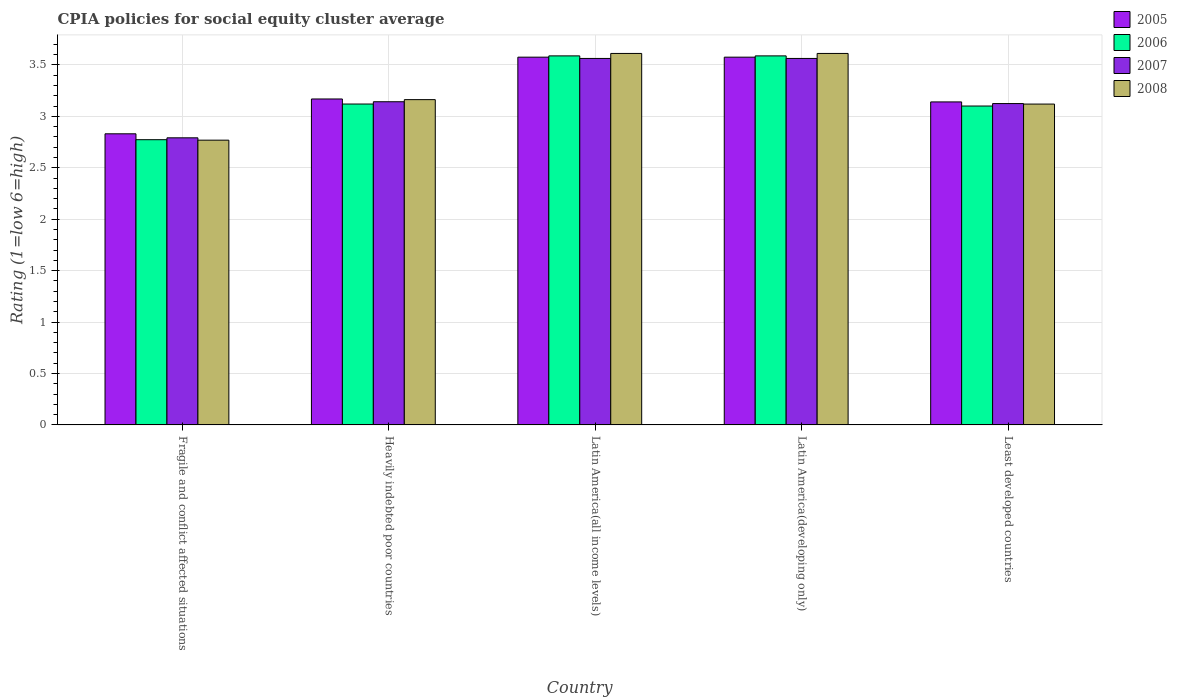How many groups of bars are there?
Provide a succinct answer. 5. What is the label of the 2nd group of bars from the left?
Provide a succinct answer. Heavily indebted poor countries. What is the CPIA rating in 2005 in Least developed countries?
Your answer should be very brief. 3.14. Across all countries, what is the maximum CPIA rating in 2007?
Provide a succinct answer. 3.56. Across all countries, what is the minimum CPIA rating in 2008?
Offer a terse response. 2.77. In which country was the CPIA rating in 2008 maximum?
Keep it short and to the point. Latin America(all income levels). In which country was the CPIA rating in 2008 minimum?
Ensure brevity in your answer.  Fragile and conflict affected situations. What is the total CPIA rating in 2008 in the graph?
Give a very brief answer. 16.27. What is the difference between the CPIA rating in 2008 in Latin America(all income levels) and that in Latin America(developing only)?
Make the answer very short. 0. What is the difference between the CPIA rating in 2008 in Heavily indebted poor countries and the CPIA rating in 2007 in Latin America(developing only)?
Provide a short and direct response. -0.4. What is the average CPIA rating in 2006 per country?
Provide a short and direct response. 3.23. What is the difference between the CPIA rating of/in 2007 and CPIA rating of/in 2006 in Fragile and conflict affected situations?
Offer a terse response. 0.02. In how many countries, is the CPIA rating in 2007 greater than 0.5?
Make the answer very short. 5. What is the ratio of the CPIA rating in 2006 in Fragile and conflict affected situations to that in Heavily indebted poor countries?
Ensure brevity in your answer.  0.89. What is the difference between the highest and the second highest CPIA rating in 2005?
Your response must be concise. -0.41. What is the difference between the highest and the lowest CPIA rating in 2006?
Your response must be concise. 0.81. In how many countries, is the CPIA rating in 2007 greater than the average CPIA rating in 2007 taken over all countries?
Offer a very short reply. 2. Is it the case that in every country, the sum of the CPIA rating in 2005 and CPIA rating in 2008 is greater than the sum of CPIA rating in 2007 and CPIA rating in 2006?
Your response must be concise. No. What does the 2nd bar from the right in Latin America(developing only) represents?
Ensure brevity in your answer.  2007. Is it the case that in every country, the sum of the CPIA rating in 2008 and CPIA rating in 2005 is greater than the CPIA rating in 2006?
Your response must be concise. Yes. What is the difference between two consecutive major ticks on the Y-axis?
Provide a short and direct response. 0.5. Where does the legend appear in the graph?
Your answer should be compact. Top right. How are the legend labels stacked?
Offer a very short reply. Vertical. What is the title of the graph?
Provide a short and direct response. CPIA policies for social equity cluster average. What is the label or title of the X-axis?
Your response must be concise. Country. What is the label or title of the Y-axis?
Your answer should be very brief. Rating (1=low 6=high). What is the Rating (1=low 6=high) in 2005 in Fragile and conflict affected situations?
Keep it short and to the point. 2.83. What is the Rating (1=low 6=high) of 2006 in Fragile and conflict affected situations?
Make the answer very short. 2.77. What is the Rating (1=low 6=high) of 2007 in Fragile and conflict affected situations?
Offer a very short reply. 2.79. What is the Rating (1=low 6=high) of 2008 in Fragile and conflict affected situations?
Give a very brief answer. 2.77. What is the Rating (1=low 6=high) in 2005 in Heavily indebted poor countries?
Make the answer very short. 3.17. What is the Rating (1=low 6=high) of 2006 in Heavily indebted poor countries?
Keep it short and to the point. 3.12. What is the Rating (1=low 6=high) of 2007 in Heavily indebted poor countries?
Offer a very short reply. 3.14. What is the Rating (1=low 6=high) in 2008 in Heavily indebted poor countries?
Keep it short and to the point. 3.16. What is the Rating (1=low 6=high) in 2005 in Latin America(all income levels)?
Provide a short and direct response. 3.58. What is the Rating (1=low 6=high) of 2006 in Latin America(all income levels)?
Offer a very short reply. 3.59. What is the Rating (1=low 6=high) in 2007 in Latin America(all income levels)?
Your response must be concise. 3.56. What is the Rating (1=low 6=high) in 2008 in Latin America(all income levels)?
Make the answer very short. 3.61. What is the Rating (1=low 6=high) of 2005 in Latin America(developing only)?
Provide a succinct answer. 3.58. What is the Rating (1=low 6=high) in 2006 in Latin America(developing only)?
Provide a succinct answer. 3.59. What is the Rating (1=low 6=high) in 2007 in Latin America(developing only)?
Provide a short and direct response. 3.56. What is the Rating (1=low 6=high) in 2008 in Latin America(developing only)?
Keep it short and to the point. 3.61. What is the Rating (1=low 6=high) in 2005 in Least developed countries?
Keep it short and to the point. 3.14. What is the Rating (1=low 6=high) in 2007 in Least developed countries?
Ensure brevity in your answer.  3.12. What is the Rating (1=low 6=high) in 2008 in Least developed countries?
Your answer should be compact. 3.12. Across all countries, what is the maximum Rating (1=low 6=high) in 2005?
Ensure brevity in your answer.  3.58. Across all countries, what is the maximum Rating (1=low 6=high) in 2006?
Offer a terse response. 3.59. Across all countries, what is the maximum Rating (1=low 6=high) in 2007?
Keep it short and to the point. 3.56. Across all countries, what is the maximum Rating (1=low 6=high) of 2008?
Your answer should be very brief. 3.61. Across all countries, what is the minimum Rating (1=low 6=high) of 2005?
Your answer should be compact. 2.83. Across all countries, what is the minimum Rating (1=low 6=high) in 2006?
Offer a very short reply. 2.77. Across all countries, what is the minimum Rating (1=low 6=high) of 2007?
Ensure brevity in your answer.  2.79. Across all countries, what is the minimum Rating (1=low 6=high) in 2008?
Your answer should be very brief. 2.77. What is the total Rating (1=low 6=high) in 2005 in the graph?
Provide a succinct answer. 16.29. What is the total Rating (1=low 6=high) of 2006 in the graph?
Offer a very short reply. 16.17. What is the total Rating (1=low 6=high) in 2007 in the graph?
Provide a succinct answer. 16.18. What is the total Rating (1=low 6=high) of 2008 in the graph?
Give a very brief answer. 16.27. What is the difference between the Rating (1=low 6=high) in 2005 in Fragile and conflict affected situations and that in Heavily indebted poor countries?
Offer a terse response. -0.34. What is the difference between the Rating (1=low 6=high) in 2006 in Fragile and conflict affected situations and that in Heavily indebted poor countries?
Offer a terse response. -0.35. What is the difference between the Rating (1=low 6=high) in 2007 in Fragile and conflict affected situations and that in Heavily indebted poor countries?
Offer a very short reply. -0.35. What is the difference between the Rating (1=low 6=high) of 2008 in Fragile and conflict affected situations and that in Heavily indebted poor countries?
Make the answer very short. -0.39. What is the difference between the Rating (1=low 6=high) of 2005 in Fragile and conflict affected situations and that in Latin America(all income levels)?
Your answer should be very brief. -0.74. What is the difference between the Rating (1=low 6=high) of 2006 in Fragile and conflict affected situations and that in Latin America(all income levels)?
Your answer should be very brief. -0.81. What is the difference between the Rating (1=low 6=high) in 2007 in Fragile and conflict affected situations and that in Latin America(all income levels)?
Offer a very short reply. -0.77. What is the difference between the Rating (1=low 6=high) in 2008 in Fragile and conflict affected situations and that in Latin America(all income levels)?
Ensure brevity in your answer.  -0.84. What is the difference between the Rating (1=low 6=high) of 2005 in Fragile and conflict affected situations and that in Latin America(developing only)?
Your answer should be very brief. -0.74. What is the difference between the Rating (1=low 6=high) of 2006 in Fragile and conflict affected situations and that in Latin America(developing only)?
Make the answer very short. -0.81. What is the difference between the Rating (1=low 6=high) in 2007 in Fragile and conflict affected situations and that in Latin America(developing only)?
Give a very brief answer. -0.77. What is the difference between the Rating (1=low 6=high) in 2008 in Fragile and conflict affected situations and that in Latin America(developing only)?
Offer a very short reply. -0.84. What is the difference between the Rating (1=low 6=high) in 2005 in Fragile and conflict affected situations and that in Least developed countries?
Your answer should be compact. -0.31. What is the difference between the Rating (1=low 6=high) of 2006 in Fragile and conflict affected situations and that in Least developed countries?
Your answer should be compact. -0.33. What is the difference between the Rating (1=low 6=high) in 2007 in Fragile and conflict affected situations and that in Least developed countries?
Provide a succinct answer. -0.33. What is the difference between the Rating (1=low 6=high) of 2008 in Fragile and conflict affected situations and that in Least developed countries?
Offer a terse response. -0.35. What is the difference between the Rating (1=low 6=high) of 2005 in Heavily indebted poor countries and that in Latin America(all income levels)?
Ensure brevity in your answer.  -0.41. What is the difference between the Rating (1=low 6=high) of 2006 in Heavily indebted poor countries and that in Latin America(all income levels)?
Your answer should be compact. -0.47. What is the difference between the Rating (1=low 6=high) in 2007 in Heavily indebted poor countries and that in Latin America(all income levels)?
Your answer should be compact. -0.42. What is the difference between the Rating (1=low 6=high) of 2008 in Heavily indebted poor countries and that in Latin America(all income levels)?
Offer a terse response. -0.45. What is the difference between the Rating (1=low 6=high) in 2005 in Heavily indebted poor countries and that in Latin America(developing only)?
Provide a succinct answer. -0.41. What is the difference between the Rating (1=low 6=high) of 2006 in Heavily indebted poor countries and that in Latin America(developing only)?
Provide a short and direct response. -0.47. What is the difference between the Rating (1=low 6=high) in 2007 in Heavily indebted poor countries and that in Latin America(developing only)?
Provide a succinct answer. -0.42. What is the difference between the Rating (1=low 6=high) of 2008 in Heavily indebted poor countries and that in Latin America(developing only)?
Make the answer very short. -0.45. What is the difference between the Rating (1=low 6=high) of 2005 in Heavily indebted poor countries and that in Least developed countries?
Make the answer very short. 0.03. What is the difference between the Rating (1=low 6=high) of 2006 in Heavily indebted poor countries and that in Least developed countries?
Make the answer very short. 0.02. What is the difference between the Rating (1=low 6=high) in 2007 in Heavily indebted poor countries and that in Least developed countries?
Give a very brief answer. 0.02. What is the difference between the Rating (1=low 6=high) of 2008 in Heavily indebted poor countries and that in Least developed countries?
Offer a very short reply. 0.04. What is the difference between the Rating (1=low 6=high) in 2006 in Latin America(all income levels) and that in Latin America(developing only)?
Offer a very short reply. 0. What is the difference between the Rating (1=low 6=high) in 2007 in Latin America(all income levels) and that in Latin America(developing only)?
Provide a succinct answer. 0. What is the difference between the Rating (1=low 6=high) of 2008 in Latin America(all income levels) and that in Latin America(developing only)?
Provide a succinct answer. 0. What is the difference between the Rating (1=low 6=high) of 2005 in Latin America(all income levels) and that in Least developed countries?
Offer a very short reply. 0.43. What is the difference between the Rating (1=low 6=high) of 2006 in Latin America(all income levels) and that in Least developed countries?
Your response must be concise. 0.49. What is the difference between the Rating (1=low 6=high) in 2007 in Latin America(all income levels) and that in Least developed countries?
Provide a short and direct response. 0.44. What is the difference between the Rating (1=low 6=high) in 2008 in Latin America(all income levels) and that in Least developed countries?
Offer a terse response. 0.49. What is the difference between the Rating (1=low 6=high) of 2005 in Latin America(developing only) and that in Least developed countries?
Ensure brevity in your answer.  0.43. What is the difference between the Rating (1=low 6=high) in 2006 in Latin America(developing only) and that in Least developed countries?
Your response must be concise. 0.49. What is the difference between the Rating (1=low 6=high) in 2007 in Latin America(developing only) and that in Least developed countries?
Give a very brief answer. 0.44. What is the difference between the Rating (1=low 6=high) of 2008 in Latin America(developing only) and that in Least developed countries?
Your response must be concise. 0.49. What is the difference between the Rating (1=low 6=high) in 2005 in Fragile and conflict affected situations and the Rating (1=low 6=high) in 2006 in Heavily indebted poor countries?
Ensure brevity in your answer.  -0.29. What is the difference between the Rating (1=low 6=high) of 2005 in Fragile and conflict affected situations and the Rating (1=low 6=high) of 2007 in Heavily indebted poor countries?
Offer a very short reply. -0.31. What is the difference between the Rating (1=low 6=high) in 2005 in Fragile and conflict affected situations and the Rating (1=low 6=high) in 2008 in Heavily indebted poor countries?
Keep it short and to the point. -0.33. What is the difference between the Rating (1=low 6=high) of 2006 in Fragile and conflict affected situations and the Rating (1=low 6=high) of 2007 in Heavily indebted poor countries?
Give a very brief answer. -0.37. What is the difference between the Rating (1=low 6=high) in 2006 in Fragile and conflict affected situations and the Rating (1=low 6=high) in 2008 in Heavily indebted poor countries?
Keep it short and to the point. -0.39. What is the difference between the Rating (1=low 6=high) of 2007 in Fragile and conflict affected situations and the Rating (1=low 6=high) of 2008 in Heavily indebted poor countries?
Give a very brief answer. -0.37. What is the difference between the Rating (1=low 6=high) of 2005 in Fragile and conflict affected situations and the Rating (1=low 6=high) of 2006 in Latin America(all income levels)?
Keep it short and to the point. -0.76. What is the difference between the Rating (1=low 6=high) of 2005 in Fragile and conflict affected situations and the Rating (1=low 6=high) of 2007 in Latin America(all income levels)?
Give a very brief answer. -0.73. What is the difference between the Rating (1=low 6=high) in 2005 in Fragile and conflict affected situations and the Rating (1=low 6=high) in 2008 in Latin America(all income levels)?
Your response must be concise. -0.78. What is the difference between the Rating (1=low 6=high) of 2006 in Fragile and conflict affected situations and the Rating (1=low 6=high) of 2007 in Latin America(all income levels)?
Offer a terse response. -0.79. What is the difference between the Rating (1=low 6=high) in 2006 in Fragile and conflict affected situations and the Rating (1=low 6=high) in 2008 in Latin America(all income levels)?
Your answer should be compact. -0.84. What is the difference between the Rating (1=low 6=high) of 2007 in Fragile and conflict affected situations and the Rating (1=low 6=high) of 2008 in Latin America(all income levels)?
Offer a very short reply. -0.82. What is the difference between the Rating (1=low 6=high) in 2005 in Fragile and conflict affected situations and the Rating (1=low 6=high) in 2006 in Latin America(developing only)?
Provide a succinct answer. -0.76. What is the difference between the Rating (1=low 6=high) in 2005 in Fragile and conflict affected situations and the Rating (1=low 6=high) in 2007 in Latin America(developing only)?
Provide a short and direct response. -0.73. What is the difference between the Rating (1=low 6=high) in 2005 in Fragile and conflict affected situations and the Rating (1=low 6=high) in 2008 in Latin America(developing only)?
Your answer should be compact. -0.78. What is the difference between the Rating (1=low 6=high) of 2006 in Fragile and conflict affected situations and the Rating (1=low 6=high) of 2007 in Latin America(developing only)?
Ensure brevity in your answer.  -0.79. What is the difference between the Rating (1=low 6=high) of 2006 in Fragile and conflict affected situations and the Rating (1=low 6=high) of 2008 in Latin America(developing only)?
Offer a very short reply. -0.84. What is the difference between the Rating (1=low 6=high) in 2007 in Fragile and conflict affected situations and the Rating (1=low 6=high) in 2008 in Latin America(developing only)?
Make the answer very short. -0.82. What is the difference between the Rating (1=low 6=high) in 2005 in Fragile and conflict affected situations and the Rating (1=low 6=high) in 2006 in Least developed countries?
Your response must be concise. -0.27. What is the difference between the Rating (1=low 6=high) of 2005 in Fragile and conflict affected situations and the Rating (1=low 6=high) of 2007 in Least developed countries?
Offer a very short reply. -0.29. What is the difference between the Rating (1=low 6=high) of 2005 in Fragile and conflict affected situations and the Rating (1=low 6=high) of 2008 in Least developed countries?
Offer a very short reply. -0.29. What is the difference between the Rating (1=low 6=high) of 2006 in Fragile and conflict affected situations and the Rating (1=low 6=high) of 2007 in Least developed countries?
Ensure brevity in your answer.  -0.35. What is the difference between the Rating (1=low 6=high) of 2006 in Fragile and conflict affected situations and the Rating (1=low 6=high) of 2008 in Least developed countries?
Your answer should be very brief. -0.35. What is the difference between the Rating (1=low 6=high) of 2007 in Fragile and conflict affected situations and the Rating (1=low 6=high) of 2008 in Least developed countries?
Offer a very short reply. -0.33. What is the difference between the Rating (1=low 6=high) in 2005 in Heavily indebted poor countries and the Rating (1=low 6=high) in 2006 in Latin America(all income levels)?
Provide a short and direct response. -0.42. What is the difference between the Rating (1=low 6=high) of 2005 in Heavily indebted poor countries and the Rating (1=low 6=high) of 2007 in Latin America(all income levels)?
Provide a short and direct response. -0.39. What is the difference between the Rating (1=low 6=high) in 2005 in Heavily indebted poor countries and the Rating (1=low 6=high) in 2008 in Latin America(all income levels)?
Provide a short and direct response. -0.44. What is the difference between the Rating (1=low 6=high) of 2006 in Heavily indebted poor countries and the Rating (1=low 6=high) of 2007 in Latin America(all income levels)?
Ensure brevity in your answer.  -0.44. What is the difference between the Rating (1=low 6=high) of 2006 in Heavily indebted poor countries and the Rating (1=low 6=high) of 2008 in Latin America(all income levels)?
Offer a very short reply. -0.49. What is the difference between the Rating (1=low 6=high) in 2007 in Heavily indebted poor countries and the Rating (1=low 6=high) in 2008 in Latin America(all income levels)?
Provide a short and direct response. -0.47. What is the difference between the Rating (1=low 6=high) in 2005 in Heavily indebted poor countries and the Rating (1=low 6=high) in 2006 in Latin America(developing only)?
Offer a terse response. -0.42. What is the difference between the Rating (1=low 6=high) in 2005 in Heavily indebted poor countries and the Rating (1=low 6=high) in 2007 in Latin America(developing only)?
Ensure brevity in your answer.  -0.39. What is the difference between the Rating (1=low 6=high) of 2005 in Heavily indebted poor countries and the Rating (1=low 6=high) of 2008 in Latin America(developing only)?
Your response must be concise. -0.44. What is the difference between the Rating (1=low 6=high) of 2006 in Heavily indebted poor countries and the Rating (1=low 6=high) of 2007 in Latin America(developing only)?
Your response must be concise. -0.44. What is the difference between the Rating (1=low 6=high) in 2006 in Heavily indebted poor countries and the Rating (1=low 6=high) in 2008 in Latin America(developing only)?
Your answer should be very brief. -0.49. What is the difference between the Rating (1=low 6=high) in 2007 in Heavily indebted poor countries and the Rating (1=low 6=high) in 2008 in Latin America(developing only)?
Your answer should be compact. -0.47. What is the difference between the Rating (1=low 6=high) in 2005 in Heavily indebted poor countries and the Rating (1=low 6=high) in 2006 in Least developed countries?
Offer a very short reply. 0.07. What is the difference between the Rating (1=low 6=high) in 2005 in Heavily indebted poor countries and the Rating (1=low 6=high) in 2007 in Least developed countries?
Your answer should be compact. 0.04. What is the difference between the Rating (1=low 6=high) of 2005 in Heavily indebted poor countries and the Rating (1=low 6=high) of 2008 in Least developed countries?
Your response must be concise. 0.05. What is the difference between the Rating (1=low 6=high) in 2006 in Heavily indebted poor countries and the Rating (1=low 6=high) in 2007 in Least developed countries?
Make the answer very short. -0. What is the difference between the Rating (1=low 6=high) in 2007 in Heavily indebted poor countries and the Rating (1=low 6=high) in 2008 in Least developed countries?
Provide a succinct answer. 0.02. What is the difference between the Rating (1=low 6=high) in 2005 in Latin America(all income levels) and the Rating (1=low 6=high) in 2006 in Latin America(developing only)?
Give a very brief answer. -0.01. What is the difference between the Rating (1=low 6=high) of 2005 in Latin America(all income levels) and the Rating (1=low 6=high) of 2007 in Latin America(developing only)?
Make the answer very short. 0.01. What is the difference between the Rating (1=low 6=high) in 2005 in Latin America(all income levels) and the Rating (1=low 6=high) in 2008 in Latin America(developing only)?
Your response must be concise. -0.04. What is the difference between the Rating (1=low 6=high) of 2006 in Latin America(all income levels) and the Rating (1=low 6=high) of 2007 in Latin America(developing only)?
Offer a very short reply. 0.03. What is the difference between the Rating (1=low 6=high) in 2006 in Latin America(all income levels) and the Rating (1=low 6=high) in 2008 in Latin America(developing only)?
Provide a succinct answer. -0.02. What is the difference between the Rating (1=low 6=high) in 2007 in Latin America(all income levels) and the Rating (1=low 6=high) in 2008 in Latin America(developing only)?
Keep it short and to the point. -0.05. What is the difference between the Rating (1=low 6=high) of 2005 in Latin America(all income levels) and the Rating (1=low 6=high) of 2006 in Least developed countries?
Your response must be concise. 0.47. What is the difference between the Rating (1=low 6=high) of 2005 in Latin America(all income levels) and the Rating (1=low 6=high) of 2007 in Least developed countries?
Keep it short and to the point. 0.45. What is the difference between the Rating (1=low 6=high) in 2005 in Latin America(all income levels) and the Rating (1=low 6=high) in 2008 in Least developed countries?
Provide a succinct answer. 0.46. What is the difference between the Rating (1=low 6=high) of 2006 in Latin America(all income levels) and the Rating (1=low 6=high) of 2007 in Least developed countries?
Your response must be concise. 0.46. What is the difference between the Rating (1=low 6=high) in 2006 in Latin America(all income levels) and the Rating (1=low 6=high) in 2008 in Least developed countries?
Your answer should be very brief. 0.47. What is the difference between the Rating (1=low 6=high) in 2007 in Latin America(all income levels) and the Rating (1=low 6=high) in 2008 in Least developed countries?
Offer a very short reply. 0.44. What is the difference between the Rating (1=low 6=high) in 2005 in Latin America(developing only) and the Rating (1=low 6=high) in 2006 in Least developed countries?
Ensure brevity in your answer.  0.47. What is the difference between the Rating (1=low 6=high) of 2005 in Latin America(developing only) and the Rating (1=low 6=high) of 2007 in Least developed countries?
Make the answer very short. 0.45. What is the difference between the Rating (1=low 6=high) in 2005 in Latin America(developing only) and the Rating (1=low 6=high) in 2008 in Least developed countries?
Provide a succinct answer. 0.46. What is the difference between the Rating (1=low 6=high) of 2006 in Latin America(developing only) and the Rating (1=low 6=high) of 2007 in Least developed countries?
Provide a short and direct response. 0.46. What is the difference between the Rating (1=low 6=high) of 2006 in Latin America(developing only) and the Rating (1=low 6=high) of 2008 in Least developed countries?
Give a very brief answer. 0.47. What is the difference between the Rating (1=low 6=high) of 2007 in Latin America(developing only) and the Rating (1=low 6=high) of 2008 in Least developed countries?
Give a very brief answer. 0.44. What is the average Rating (1=low 6=high) in 2005 per country?
Provide a succinct answer. 3.26. What is the average Rating (1=low 6=high) in 2006 per country?
Provide a succinct answer. 3.23. What is the average Rating (1=low 6=high) of 2007 per country?
Your answer should be compact. 3.24. What is the average Rating (1=low 6=high) in 2008 per country?
Your response must be concise. 3.25. What is the difference between the Rating (1=low 6=high) in 2005 and Rating (1=low 6=high) in 2006 in Fragile and conflict affected situations?
Offer a terse response. 0.06. What is the difference between the Rating (1=low 6=high) in 2005 and Rating (1=low 6=high) in 2007 in Fragile and conflict affected situations?
Keep it short and to the point. 0.04. What is the difference between the Rating (1=low 6=high) of 2005 and Rating (1=low 6=high) of 2008 in Fragile and conflict affected situations?
Provide a succinct answer. 0.06. What is the difference between the Rating (1=low 6=high) of 2006 and Rating (1=low 6=high) of 2007 in Fragile and conflict affected situations?
Make the answer very short. -0.02. What is the difference between the Rating (1=low 6=high) in 2006 and Rating (1=low 6=high) in 2008 in Fragile and conflict affected situations?
Offer a terse response. 0. What is the difference between the Rating (1=low 6=high) in 2007 and Rating (1=low 6=high) in 2008 in Fragile and conflict affected situations?
Give a very brief answer. 0.02. What is the difference between the Rating (1=low 6=high) of 2005 and Rating (1=low 6=high) of 2006 in Heavily indebted poor countries?
Give a very brief answer. 0.05. What is the difference between the Rating (1=low 6=high) of 2005 and Rating (1=low 6=high) of 2007 in Heavily indebted poor countries?
Your response must be concise. 0.03. What is the difference between the Rating (1=low 6=high) in 2005 and Rating (1=low 6=high) in 2008 in Heavily indebted poor countries?
Provide a short and direct response. 0.01. What is the difference between the Rating (1=low 6=high) of 2006 and Rating (1=low 6=high) of 2007 in Heavily indebted poor countries?
Provide a short and direct response. -0.02. What is the difference between the Rating (1=low 6=high) of 2006 and Rating (1=low 6=high) of 2008 in Heavily indebted poor countries?
Offer a very short reply. -0.04. What is the difference between the Rating (1=low 6=high) of 2007 and Rating (1=low 6=high) of 2008 in Heavily indebted poor countries?
Offer a terse response. -0.02. What is the difference between the Rating (1=low 6=high) of 2005 and Rating (1=low 6=high) of 2006 in Latin America(all income levels)?
Offer a very short reply. -0.01. What is the difference between the Rating (1=low 6=high) in 2005 and Rating (1=low 6=high) in 2007 in Latin America(all income levels)?
Your answer should be very brief. 0.01. What is the difference between the Rating (1=low 6=high) of 2005 and Rating (1=low 6=high) of 2008 in Latin America(all income levels)?
Provide a short and direct response. -0.04. What is the difference between the Rating (1=low 6=high) of 2006 and Rating (1=low 6=high) of 2007 in Latin America(all income levels)?
Keep it short and to the point. 0.03. What is the difference between the Rating (1=low 6=high) of 2006 and Rating (1=low 6=high) of 2008 in Latin America(all income levels)?
Your response must be concise. -0.02. What is the difference between the Rating (1=low 6=high) in 2007 and Rating (1=low 6=high) in 2008 in Latin America(all income levels)?
Offer a terse response. -0.05. What is the difference between the Rating (1=low 6=high) of 2005 and Rating (1=low 6=high) of 2006 in Latin America(developing only)?
Ensure brevity in your answer.  -0.01. What is the difference between the Rating (1=low 6=high) in 2005 and Rating (1=low 6=high) in 2007 in Latin America(developing only)?
Give a very brief answer. 0.01. What is the difference between the Rating (1=low 6=high) in 2005 and Rating (1=low 6=high) in 2008 in Latin America(developing only)?
Make the answer very short. -0.04. What is the difference between the Rating (1=low 6=high) in 2006 and Rating (1=low 6=high) in 2007 in Latin America(developing only)?
Give a very brief answer. 0.03. What is the difference between the Rating (1=low 6=high) of 2006 and Rating (1=low 6=high) of 2008 in Latin America(developing only)?
Your answer should be compact. -0.02. What is the difference between the Rating (1=low 6=high) of 2007 and Rating (1=low 6=high) of 2008 in Latin America(developing only)?
Give a very brief answer. -0.05. What is the difference between the Rating (1=low 6=high) of 2005 and Rating (1=low 6=high) of 2007 in Least developed countries?
Your answer should be compact. 0.02. What is the difference between the Rating (1=low 6=high) in 2005 and Rating (1=low 6=high) in 2008 in Least developed countries?
Offer a very short reply. 0.02. What is the difference between the Rating (1=low 6=high) of 2006 and Rating (1=low 6=high) of 2007 in Least developed countries?
Offer a very short reply. -0.02. What is the difference between the Rating (1=low 6=high) in 2006 and Rating (1=low 6=high) in 2008 in Least developed countries?
Offer a terse response. -0.02. What is the difference between the Rating (1=low 6=high) in 2007 and Rating (1=low 6=high) in 2008 in Least developed countries?
Offer a very short reply. 0. What is the ratio of the Rating (1=low 6=high) of 2005 in Fragile and conflict affected situations to that in Heavily indebted poor countries?
Give a very brief answer. 0.89. What is the ratio of the Rating (1=low 6=high) of 2007 in Fragile and conflict affected situations to that in Heavily indebted poor countries?
Your answer should be very brief. 0.89. What is the ratio of the Rating (1=low 6=high) in 2008 in Fragile and conflict affected situations to that in Heavily indebted poor countries?
Provide a short and direct response. 0.88. What is the ratio of the Rating (1=low 6=high) of 2005 in Fragile and conflict affected situations to that in Latin America(all income levels)?
Offer a very short reply. 0.79. What is the ratio of the Rating (1=low 6=high) of 2006 in Fragile and conflict affected situations to that in Latin America(all income levels)?
Offer a terse response. 0.77. What is the ratio of the Rating (1=low 6=high) of 2007 in Fragile and conflict affected situations to that in Latin America(all income levels)?
Offer a very short reply. 0.78. What is the ratio of the Rating (1=low 6=high) of 2008 in Fragile and conflict affected situations to that in Latin America(all income levels)?
Ensure brevity in your answer.  0.77. What is the ratio of the Rating (1=low 6=high) in 2005 in Fragile and conflict affected situations to that in Latin America(developing only)?
Provide a succinct answer. 0.79. What is the ratio of the Rating (1=low 6=high) in 2006 in Fragile and conflict affected situations to that in Latin America(developing only)?
Your answer should be compact. 0.77. What is the ratio of the Rating (1=low 6=high) of 2007 in Fragile and conflict affected situations to that in Latin America(developing only)?
Give a very brief answer. 0.78. What is the ratio of the Rating (1=low 6=high) of 2008 in Fragile and conflict affected situations to that in Latin America(developing only)?
Offer a terse response. 0.77. What is the ratio of the Rating (1=low 6=high) in 2005 in Fragile and conflict affected situations to that in Least developed countries?
Make the answer very short. 0.9. What is the ratio of the Rating (1=low 6=high) in 2006 in Fragile and conflict affected situations to that in Least developed countries?
Keep it short and to the point. 0.89. What is the ratio of the Rating (1=low 6=high) in 2007 in Fragile and conflict affected situations to that in Least developed countries?
Offer a terse response. 0.89. What is the ratio of the Rating (1=low 6=high) of 2008 in Fragile and conflict affected situations to that in Least developed countries?
Keep it short and to the point. 0.89. What is the ratio of the Rating (1=low 6=high) of 2005 in Heavily indebted poor countries to that in Latin America(all income levels)?
Your answer should be very brief. 0.89. What is the ratio of the Rating (1=low 6=high) of 2006 in Heavily indebted poor countries to that in Latin America(all income levels)?
Offer a very short reply. 0.87. What is the ratio of the Rating (1=low 6=high) of 2007 in Heavily indebted poor countries to that in Latin America(all income levels)?
Offer a terse response. 0.88. What is the ratio of the Rating (1=low 6=high) of 2008 in Heavily indebted poor countries to that in Latin America(all income levels)?
Your answer should be very brief. 0.88. What is the ratio of the Rating (1=low 6=high) in 2005 in Heavily indebted poor countries to that in Latin America(developing only)?
Offer a terse response. 0.89. What is the ratio of the Rating (1=low 6=high) in 2006 in Heavily indebted poor countries to that in Latin America(developing only)?
Your answer should be compact. 0.87. What is the ratio of the Rating (1=low 6=high) of 2007 in Heavily indebted poor countries to that in Latin America(developing only)?
Make the answer very short. 0.88. What is the ratio of the Rating (1=low 6=high) in 2008 in Heavily indebted poor countries to that in Latin America(developing only)?
Give a very brief answer. 0.88. What is the ratio of the Rating (1=low 6=high) of 2005 in Heavily indebted poor countries to that in Least developed countries?
Offer a terse response. 1.01. What is the ratio of the Rating (1=low 6=high) in 2006 in Heavily indebted poor countries to that in Least developed countries?
Provide a short and direct response. 1.01. What is the ratio of the Rating (1=low 6=high) in 2008 in Heavily indebted poor countries to that in Least developed countries?
Give a very brief answer. 1.01. What is the ratio of the Rating (1=low 6=high) of 2005 in Latin America(all income levels) to that in Latin America(developing only)?
Make the answer very short. 1. What is the ratio of the Rating (1=low 6=high) of 2006 in Latin America(all income levels) to that in Latin America(developing only)?
Your answer should be very brief. 1. What is the ratio of the Rating (1=low 6=high) of 2005 in Latin America(all income levels) to that in Least developed countries?
Provide a succinct answer. 1.14. What is the ratio of the Rating (1=low 6=high) of 2006 in Latin America(all income levels) to that in Least developed countries?
Your answer should be very brief. 1.16. What is the ratio of the Rating (1=low 6=high) in 2007 in Latin America(all income levels) to that in Least developed countries?
Your answer should be compact. 1.14. What is the ratio of the Rating (1=low 6=high) in 2008 in Latin America(all income levels) to that in Least developed countries?
Keep it short and to the point. 1.16. What is the ratio of the Rating (1=low 6=high) in 2005 in Latin America(developing only) to that in Least developed countries?
Make the answer very short. 1.14. What is the ratio of the Rating (1=low 6=high) in 2006 in Latin America(developing only) to that in Least developed countries?
Give a very brief answer. 1.16. What is the ratio of the Rating (1=low 6=high) of 2007 in Latin America(developing only) to that in Least developed countries?
Provide a succinct answer. 1.14. What is the ratio of the Rating (1=low 6=high) in 2008 in Latin America(developing only) to that in Least developed countries?
Provide a succinct answer. 1.16. What is the difference between the highest and the second highest Rating (1=low 6=high) in 2005?
Your answer should be compact. 0. What is the difference between the highest and the second highest Rating (1=low 6=high) in 2007?
Give a very brief answer. 0. What is the difference between the highest and the second highest Rating (1=low 6=high) in 2008?
Provide a succinct answer. 0. What is the difference between the highest and the lowest Rating (1=low 6=high) of 2005?
Provide a succinct answer. 0.74. What is the difference between the highest and the lowest Rating (1=low 6=high) in 2006?
Your answer should be very brief. 0.81. What is the difference between the highest and the lowest Rating (1=low 6=high) in 2007?
Ensure brevity in your answer.  0.77. What is the difference between the highest and the lowest Rating (1=low 6=high) of 2008?
Offer a very short reply. 0.84. 